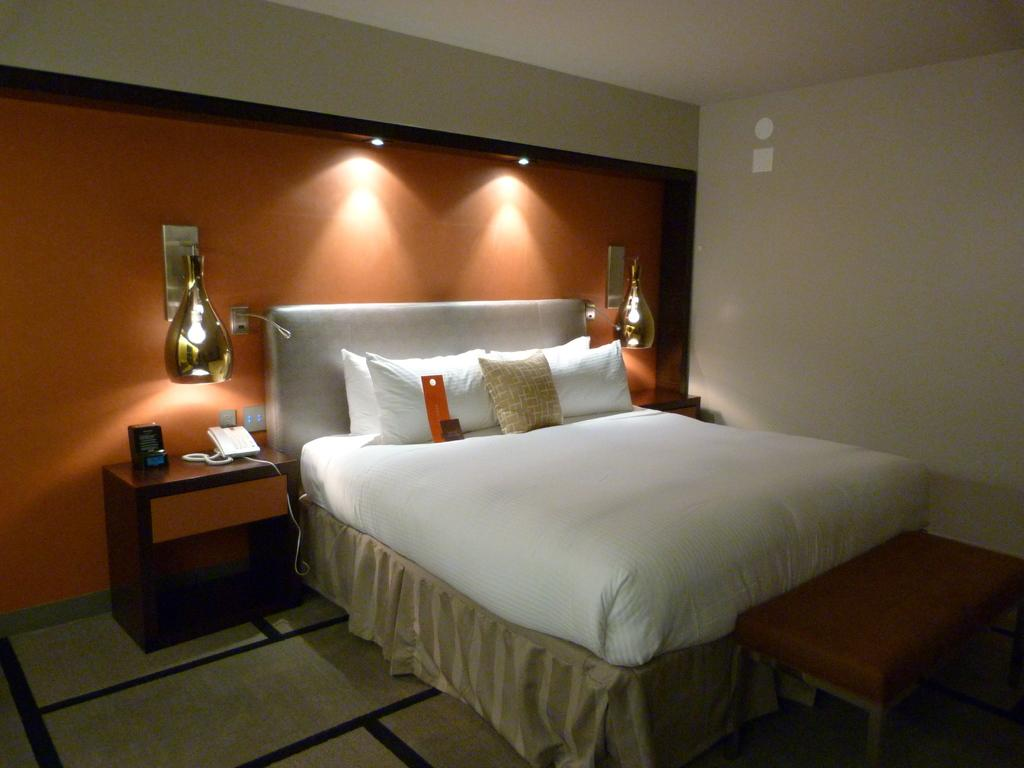What type of furniture is present in the image? There is a bed in the image. What is placed on the bed? There are pillows on the bed. What type of lighting is visible in the image? There are lamps in the image. What communication device can be seen in the image? There is a telephone in the image. Where is the nest located in the image? There is no nest present in the image. What type of apparatus is used for communication in the image? The telephone is the communication device present in the image, but it is not referred to as an "apparatus." 